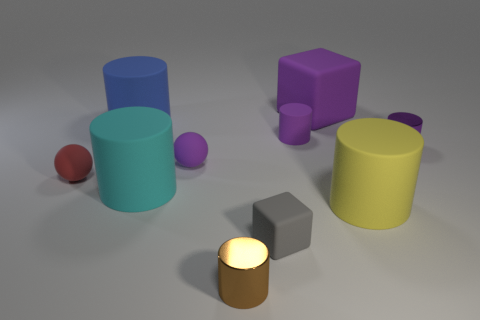Subtract all cyan cylinders. How many cylinders are left? 5 Subtract all purple rubber cylinders. How many cylinders are left? 5 Subtract all green spheres. Subtract all brown cubes. How many spheres are left? 2 Subtract all blocks. How many objects are left? 8 Add 9 yellow things. How many yellow things are left? 10 Add 4 spheres. How many spheres exist? 6 Subtract 0 red blocks. How many objects are left? 10 Subtract all large purple metal cylinders. Subtract all cyan matte cylinders. How many objects are left? 9 